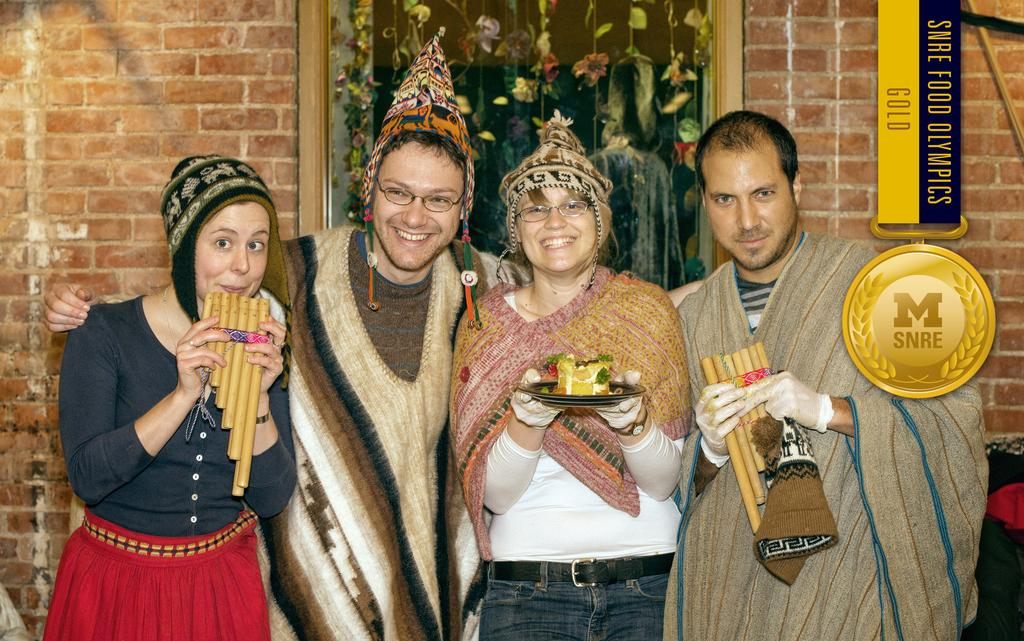Who or what can be seen in the image? There are people in the image. What else is present in the image besides the people? There are food items in the image. What can be seen in the background of the image? There is a wall and decorative objects in the background of the image. How does the earthquake affect the people and food items in the image? There is no earthquake present in the image, so its effects cannot be determined. 